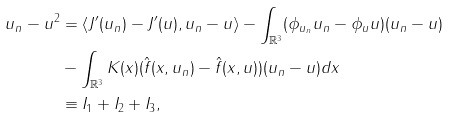<formula> <loc_0><loc_0><loc_500><loc_500>\| u _ { n } - u \| ^ { 2 } & = \langle J ^ { \prime } ( u _ { n } ) - J ^ { \prime } ( u ) , u _ { n } - u \rangle - \int _ { \mathbb { R } ^ { 3 } } ( \phi _ { u _ { n } } u _ { n } - \phi _ { u } u ) ( u _ { n } - u ) \\ & - \int _ { \mathbb { R } ^ { 3 } } K ( x ) ( \hat { f } ( x , u _ { n } ) - \hat { f } ( x , u ) ) ( u _ { n } - u ) d x \\ & \equiv I _ { 1 } + I _ { 2 } + I _ { 3 } ,</formula> 